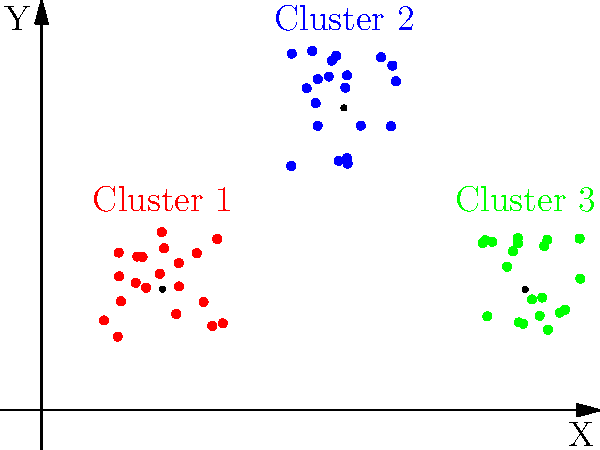As a data scientist, you've applied k-means clustering to a dataset and visualized the results in a 2D plot. The plot shows three distinct clusters with their centroids. Based on the visualization, which of the following statements is most likely true about the clustering results?

A) The algorithm failed to converge
B) The chosen k value is too high
C) The chosen k value is appropriate
D) The dataset requires additional feature engineering Let's analyze the plot step-by-step:

1. We can see three distinct groups of points, each in a different color (red, blue, and green).

2. Each group has a black dot at its approximate center, which represents the centroid of that cluster.

3. The clusters are well-separated and do not overlap significantly.

4. The points within each cluster are relatively close to each other and to their respective centroids.

5. There are no obvious outliers or points that seem to be misclassified.

6. The number of clusters (k=3) matches the number of visually distinct groups in the data.

Given these observations:

- The algorithm has clearly converged, as we can see distinct clusters with well-defined centroids.
- The chosen k value (3) appears to be appropriate, as it matches the number of natural groupings in the data.
- There's no indication that additional feature engineering is required, as the current 2D representation shows clear separation between clusters.

Therefore, the most likely true statement is that the chosen k value is appropriate. The visualization suggests that the k-means algorithm has successfully identified the natural structure in the data using k=3.
Answer: C) The chosen k value is appropriate 